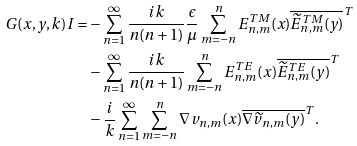<formula> <loc_0><loc_0><loc_500><loc_500>G ( x , y , k ) I = & - \sum _ { n = 1 } ^ { \infty } \frac { i { k } } { n ( n + 1 ) } \frac { \epsilon } { \mu } \sum _ { m = - n } ^ { n } E _ { n , m } ^ { T M } ( x ) \overline { \widetilde { E } _ { n , m } ^ { T M } ( y ) } ^ { T } \\ & - \sum _ { n = 1 } ^ { \infty } \frac { i { k } } { n ( n + 1 ) } \sum _ { m = - n } ^ { n } E _ { n , m } ^ { T E } ( x ) \overline { \widetilde { E } _ { n , m } ^ { T E } ( y ) } ^ { T } \\ & - \frac { i } { k } \sum _ { n = 1 } ^ { \infty } \sum _ { m = - n } ^ { n } \nabla v _ { n , m } ( x ) \overline { \nabla \widetilde { v } _ { n , m } ( y ) } ^ { T } .</formula> 